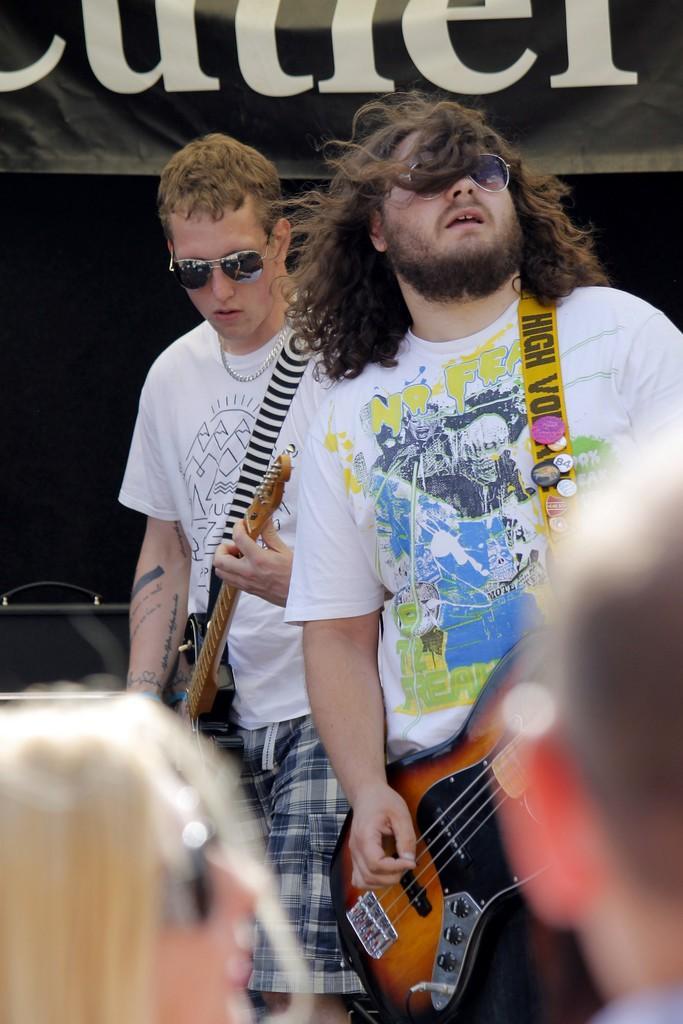In one or two sentences, can you explain what this image depicts? This image is clicked in a musical concert. There are two people who are playing musical instruments, both of them are wearing white T-shirt and goggles. A banner is on the top in the bottom there are two persons who are watching them. 